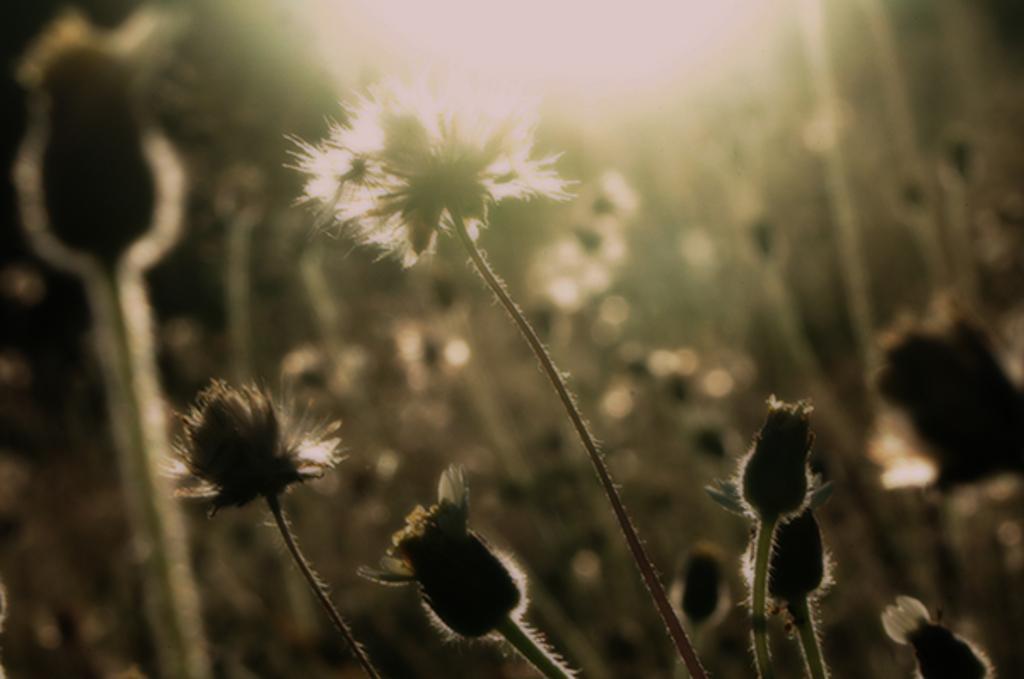Can you describe this image briefly? In the image there are flowers and flower buds with stems. In the background it is a blur image. And also there is a light. 